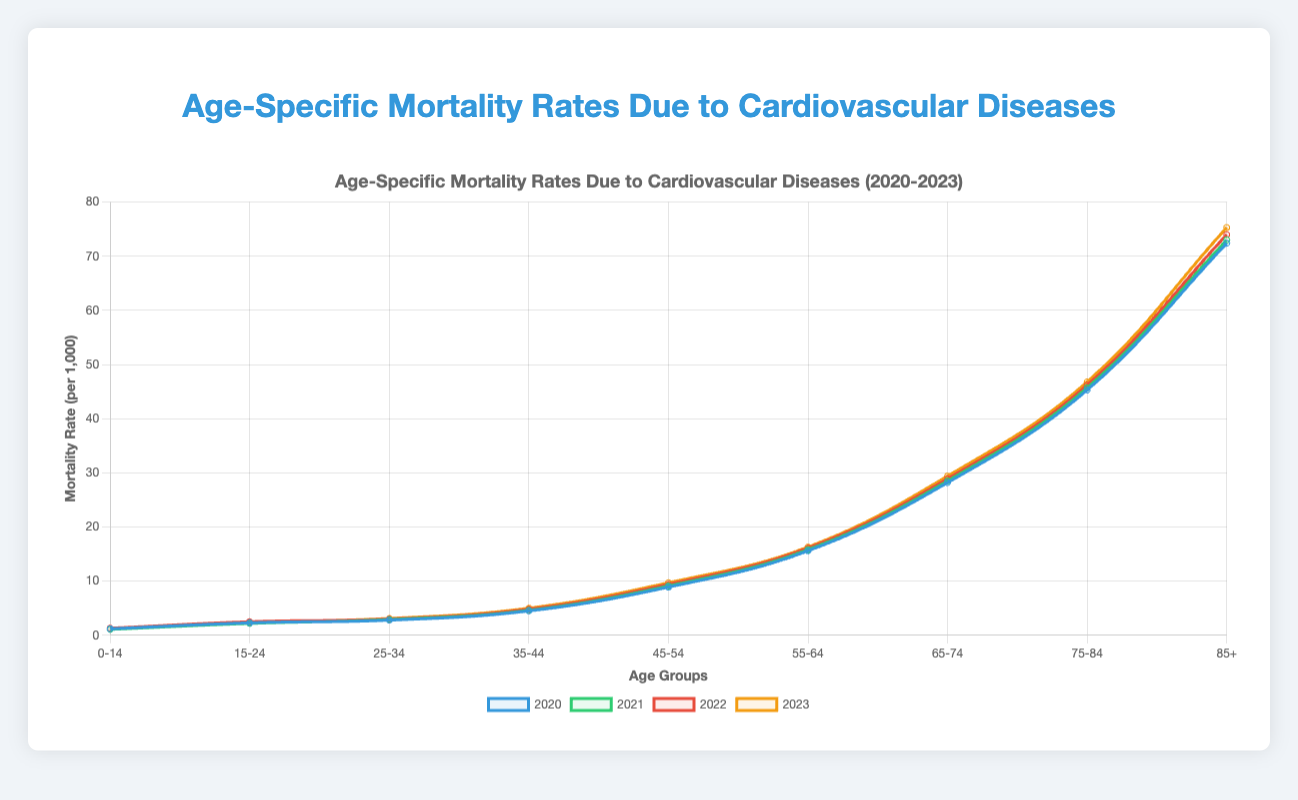What is the trend of mortality rates across all age groups from 2020 to 2023? The figure shows lines representing the mortality rates for each year. Visual inspection reveals an increasing trend in mortality rates as the age groups get older. Each year, the lines rise, indicating higher mortality rates for older age groups, with 2023 generally showing the highest rates across all age groups.
Answer: Increasing trend, with higher rates in older age groups each year Which year had the highest cardiovascular mortality rate for the age group 75-84? By examining the lines at the age group 75-84, the yellow line representing 2023 is the highest compared to the other years. Thus, 2023 had the highest mortality rate in this age group.
Answer: 2023 How does the mortality rate for the age group 45-54 in 2020 compare to that in 2023? The rate for the age group 45-54 in 2020 is 8.9, while in 2023, it is 9.7. So, the rate increased from 2020 to 2023.
Answer: Increased from 8.9 to 9.7 What is the average mortality rate for 2023 across all age groups? To find the average, sum the rates for 2023 and divide by the number of age groups: (1.2 + 2.4 + 3.1 + 5.0 + 9.7 + 16.3 + 29.4 + 46.8 + 75.3) / 9 = 21.02
Answer: 21.02 Which age group has the lowest mortality rate in 2022? The blue data points for 2022 show that the age group 0-14 has the lowest mortality rate at 1.3.
Answer: 0-14 What is the difference in the mortality rates between age groups 65-74 and 85+ in 2021? The mortality rate for age group 65-74 in 2021 is 28.5, and for 85+, it is 73.0. The difference is 73.0 - 28.5 = 44.5.
Answer: 44.5 Which city has the highest mortality rate for the age group 25-34? By comparing the rates, Houston has the highest at 2.9.
Answer: Houston Is the mortality rate for the age group 55-64 higher in 2022 or 2023? The rate in 2022 is 16.1, while in 2023, it is 16.3. The rate is higher in 2023.
Answer: 2023 What is the median mortality rate for the age group 35-44 across 2020, 2021, 2022, and 2023? The rates are: 4.5 (2020), 4.6 (2021), 4.8 (2022), and 5.0 (2023). The median is the average of the two middle numbers: (4.6 + 4.8) / 2 = 4.7
Answer: 4.7 